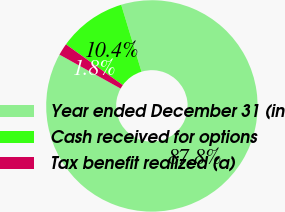Convert chart to OTSL. <chart><loc_0><loc_0><loc_500><loc_500><pie_chart><fcel>Year ended December 31 (in<fcel>Cash received for options<fcel>Tax benefit realized (a)<nl><fcel>87.75%<fcel>10.42%<fcel>1.83%<nl></chart> 